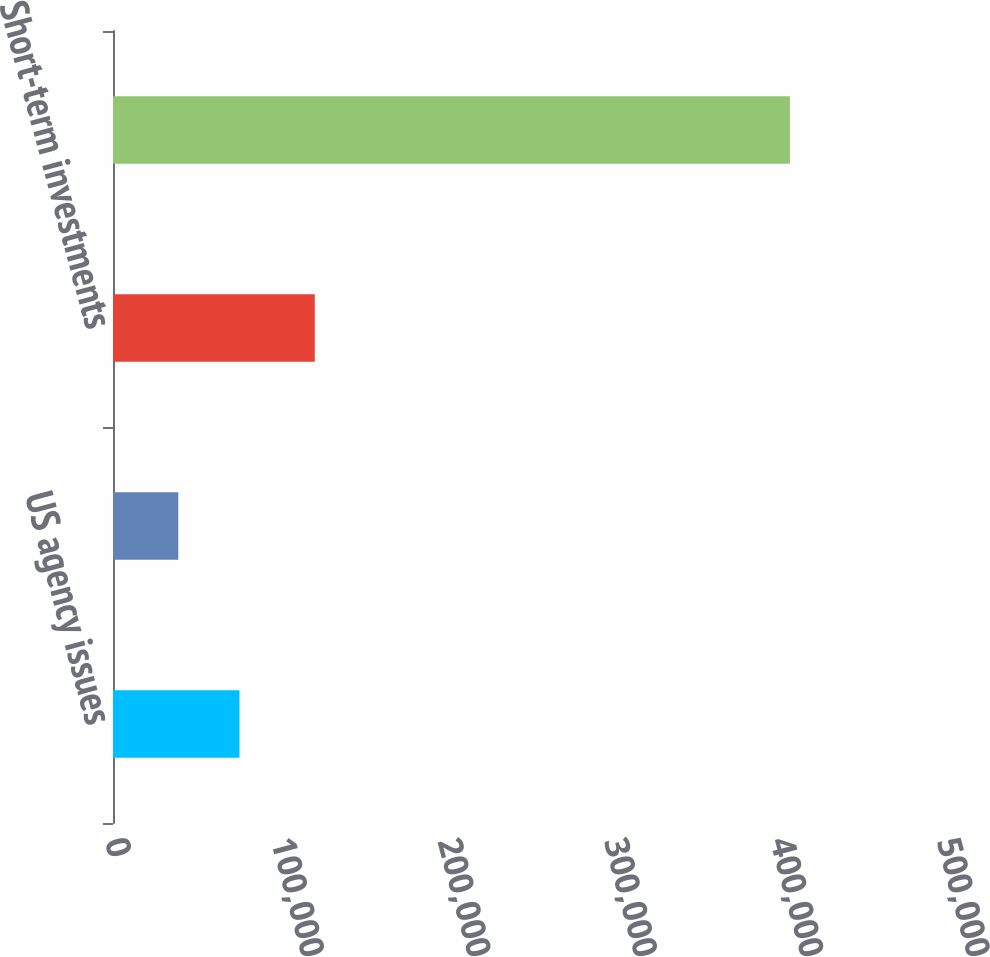<chart> <loc_0><loc_0><loc_500><loc_500><bar_chart><fcel>US agency issues<fcel>Asset-backed bonds<fcel>Short-term investments<fcel>Cash cash equivalents and<nl><fcel>75983.6<fcel>39224<fcel>121266<fcel>406820<nl></chart> 